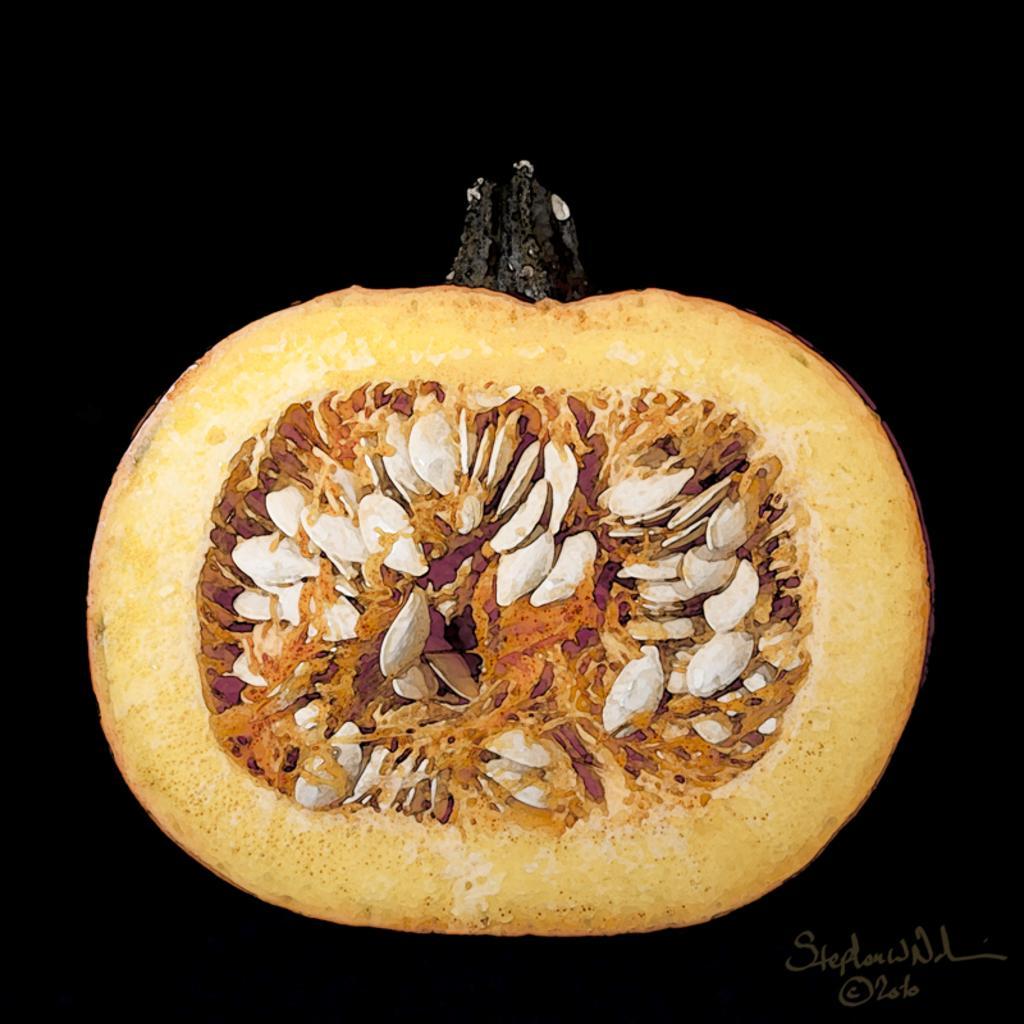How would you summarize this image in a sentence or two? In this image I can see the pumpkin in brown and white color and I can see the dark background. 